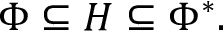<formula> <loc_0><loc_0><loc_500><loc_500>\Phi \subseteq H \subseteq \Phi ^ { * } .</formula> 